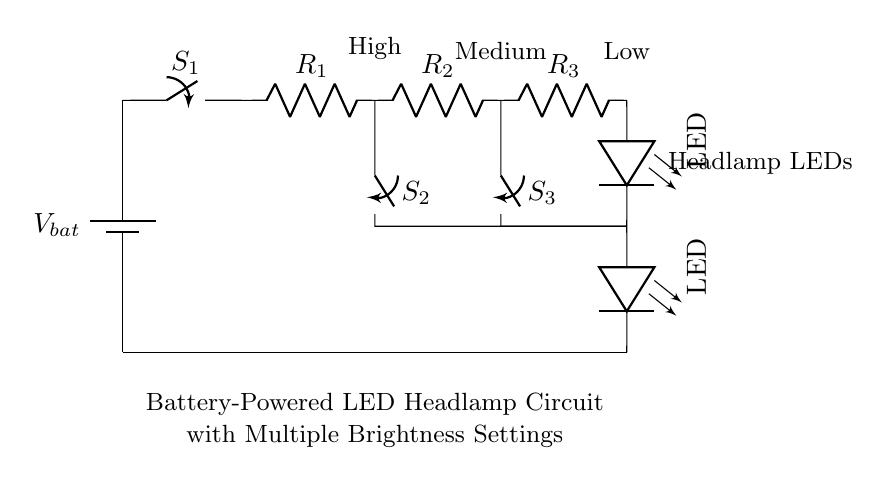What powers the circuit? The circuit is powered by a battery, which is indicated at the top of the diagram.
Answer: Battery What do the switches control? The switches control the flow of current through different resistors, which adjust the brightness of the LEDs based on the resistor selected.
Answer: Brightness settings How many LEDs are in this circuit? There are two LEDs represented in the circuit. Each LED is drawn separately below the resistors and connected in series.
Answer: Two Which switch would you use for maximum brightness? To achieve maximum brightness, you would use switch S2 associated with the smallest resistor R1, allowing the most current to flow through.
Answer: S2 What is the function of the resistors? The resistors reduce the current flowing to the LEDs, allowing for different brightness levels when different combinations of switches are toggled.
Answer: Control brightness What is the order of component connections? The order from the battery is: battery, switch S1, resistors R1, R2, R3, then LEDs, followed by closing the circuit.
Answer: Battery, switch, resistors, LEDs Which component connects the LEDs to the battery? The final connection from the LEDs to complete the circuit is made by the wire running back to the battery from the last LED.
Answer: Wire 